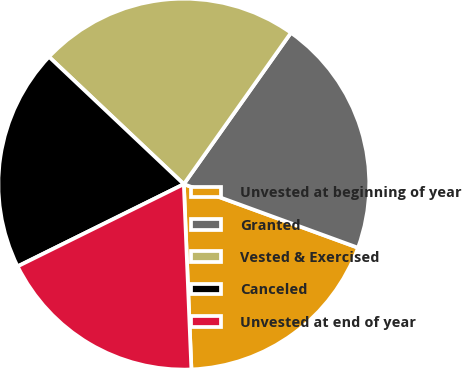Convert chart to OTSL. <chart><loc_0><loc_0><loc_500><loc_500><pie_chart><fcel>Unvested at beginning of year<fcel>Granted<fcel>Vested & Exercised<fcel>Canceled<fcel>Unvested at end of year<nl><fcel>18.78%<fcel>20.77%<fcel>22.76%<fcel>19.36%<fcel>18.34%<nl></chart> 